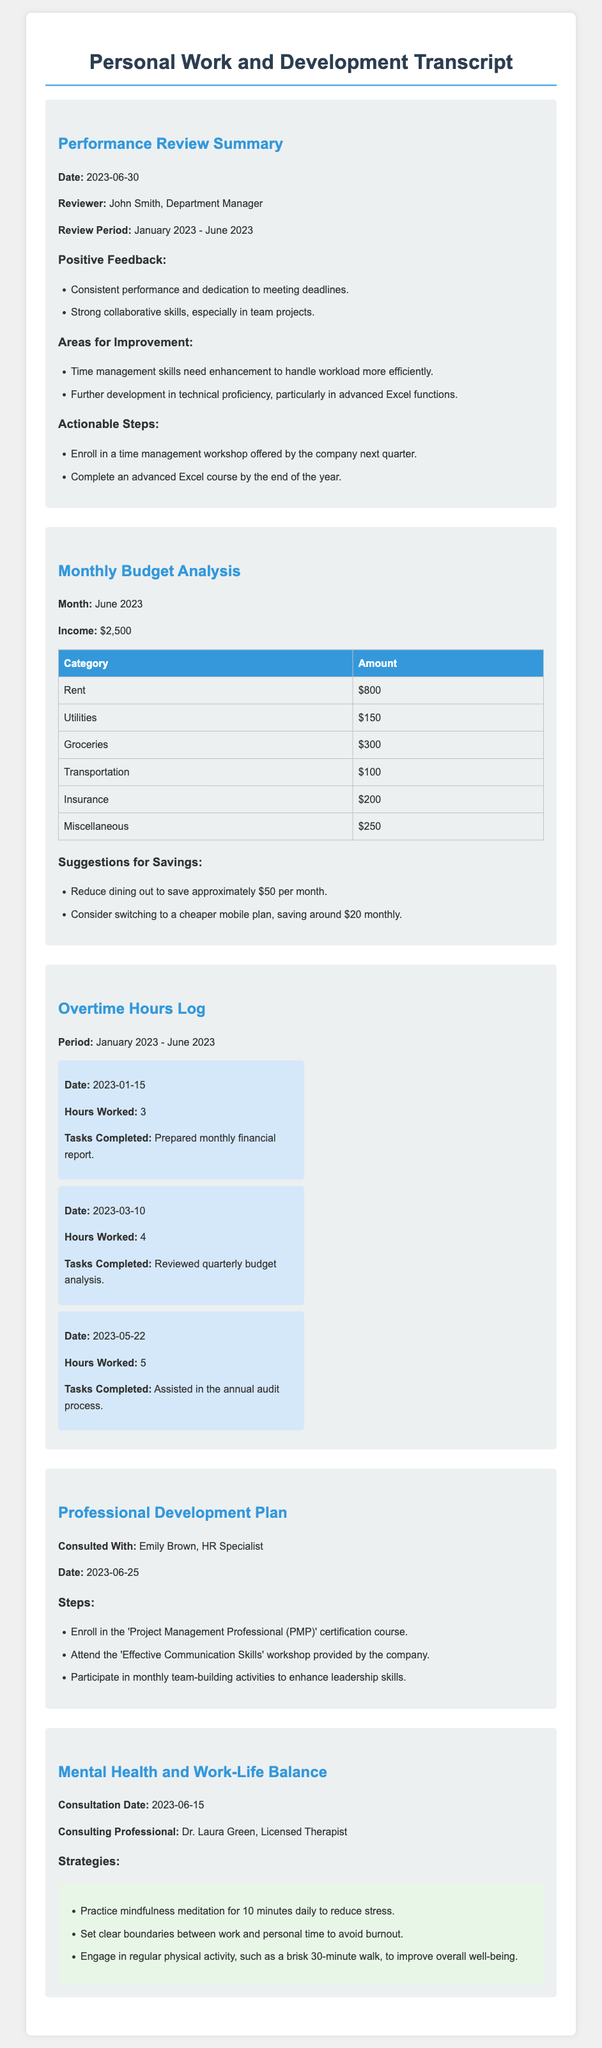What is the date of the performance review? The date of the performance review is mentioned in the summary section of the document.
Answer: 2023-06-30 Who provided the positive feedback during the performance review? The reviewer is mentioned in the performance review summary.
Answer: John Smith What was the total income for June 2023? The income is reported in the budget analysis section.
Answer: $2,500 How much was spent on groceries in June 2023? The grocery expenditure is detailed in the monthly budget analysis.
Answer: $300 What is one suggested area to save money from the budget analysis? The savings suggestions focus on areas of expenditure.
Answer: Reduce dining out How many hours were worked on overtime on January 15, 2023? Overtime hours are logged with specific dates and hours worked.
Answer: 3 Which certification course is recommended in the professional development plan? The certification is specified under the steps outlined in the professional development section.
Answer: Project Management Professional (PMP) What strategy is recommended for managing stress? Strategies for mental health and work-life balance are listed in the relevant section.
Answer: Practice mindfulness meditation What is the name of the consulting professional for the mental health session? The consulting professional is identified in the transcript.
Answer: Dr. Laura Green 